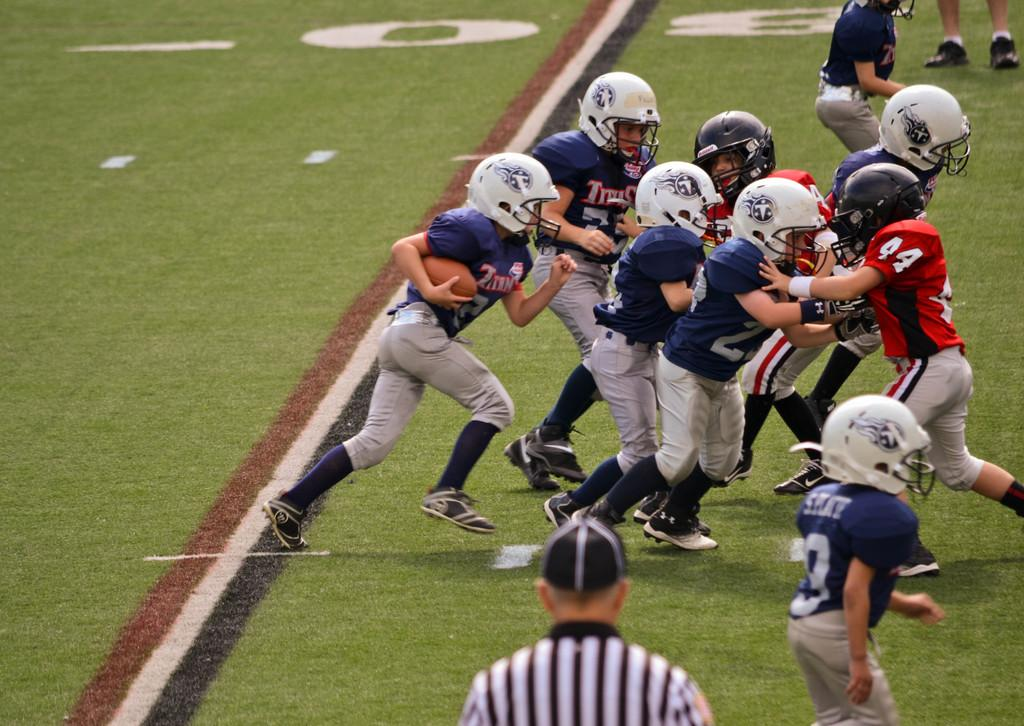What activity are the people in the image engaged in? The people in the image are playing a game. What protective gear are the people wearing? The people are wearing helmets. Who is holding the ball in the image? There is a person holding a ball in the image. Can you describe the person in front of the image? There is a person in front of the image, but no specific details are provided about their appearance or actions. What can be seen beneath the people in the image? The ground is visible in the image. What type of nose can be seen on the person in the image? There is no nose visible in the image; the people are wearing helmets that cover their faces. What type of glass is being used to play the game in the image? There is no glass present in the image; the game being played is not specified, but it does not involve any glass objects. 